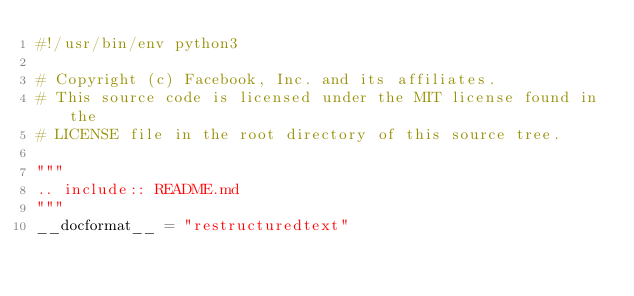Convert code to text. <code><loc_0><loc_0><loc_500><loc_500><_Python_>#!/usr/bin/env python3

# Copyright (c) Facebook, Inc. and its affiliates.
# This source code is licensed under the MIT license found in the
# LICENSE file in the root directory of this source tree.

"""
.. include:: README.md
"""
__docformat__ = "restructuredtext"
</code> 